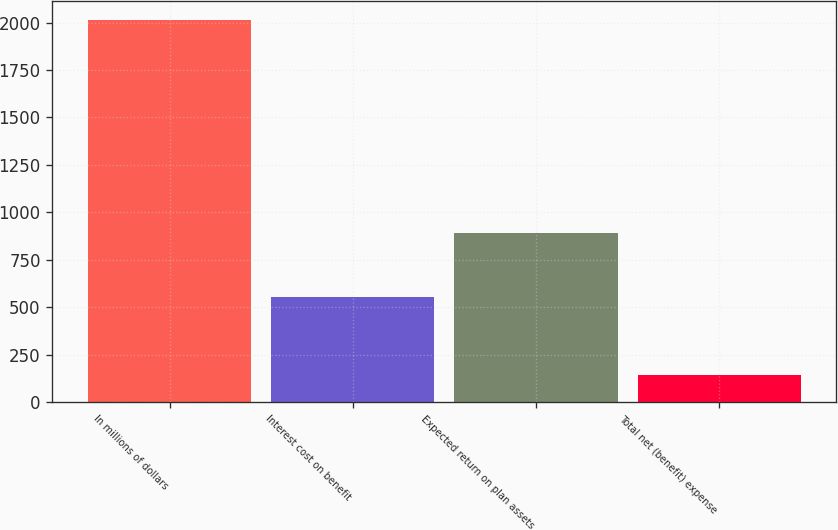<chart> <loc_0><loc_0><loc_500><loc_500><bar_chart><fcel>In millions of dollars<fcel>Interest cost on benefit<fcel>Expected return on plan assets<fcel>Total net (benefit) expense<nl><fcel>2015<fcel>553<fcel>893<fcel>143<nl></chart> 